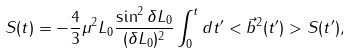<formula> <loc_0><loc_0><loc_500><loc_500>S ( t ) = - \frac { 4 } { 3 } \mu ^ { 2 } L _ { 0 } \frac { \sin ^ { 2 } \delta L _ { 0 } } { ( \delta L _ { 0 } ) ^ { 2 } } \int _ { 0 } ^ { t } d t ^ { \prime } < \vec { b } ^ { 2 } ( t ^ { \prime } ) > S ( t ^ { \prime } ) ,</formula> 